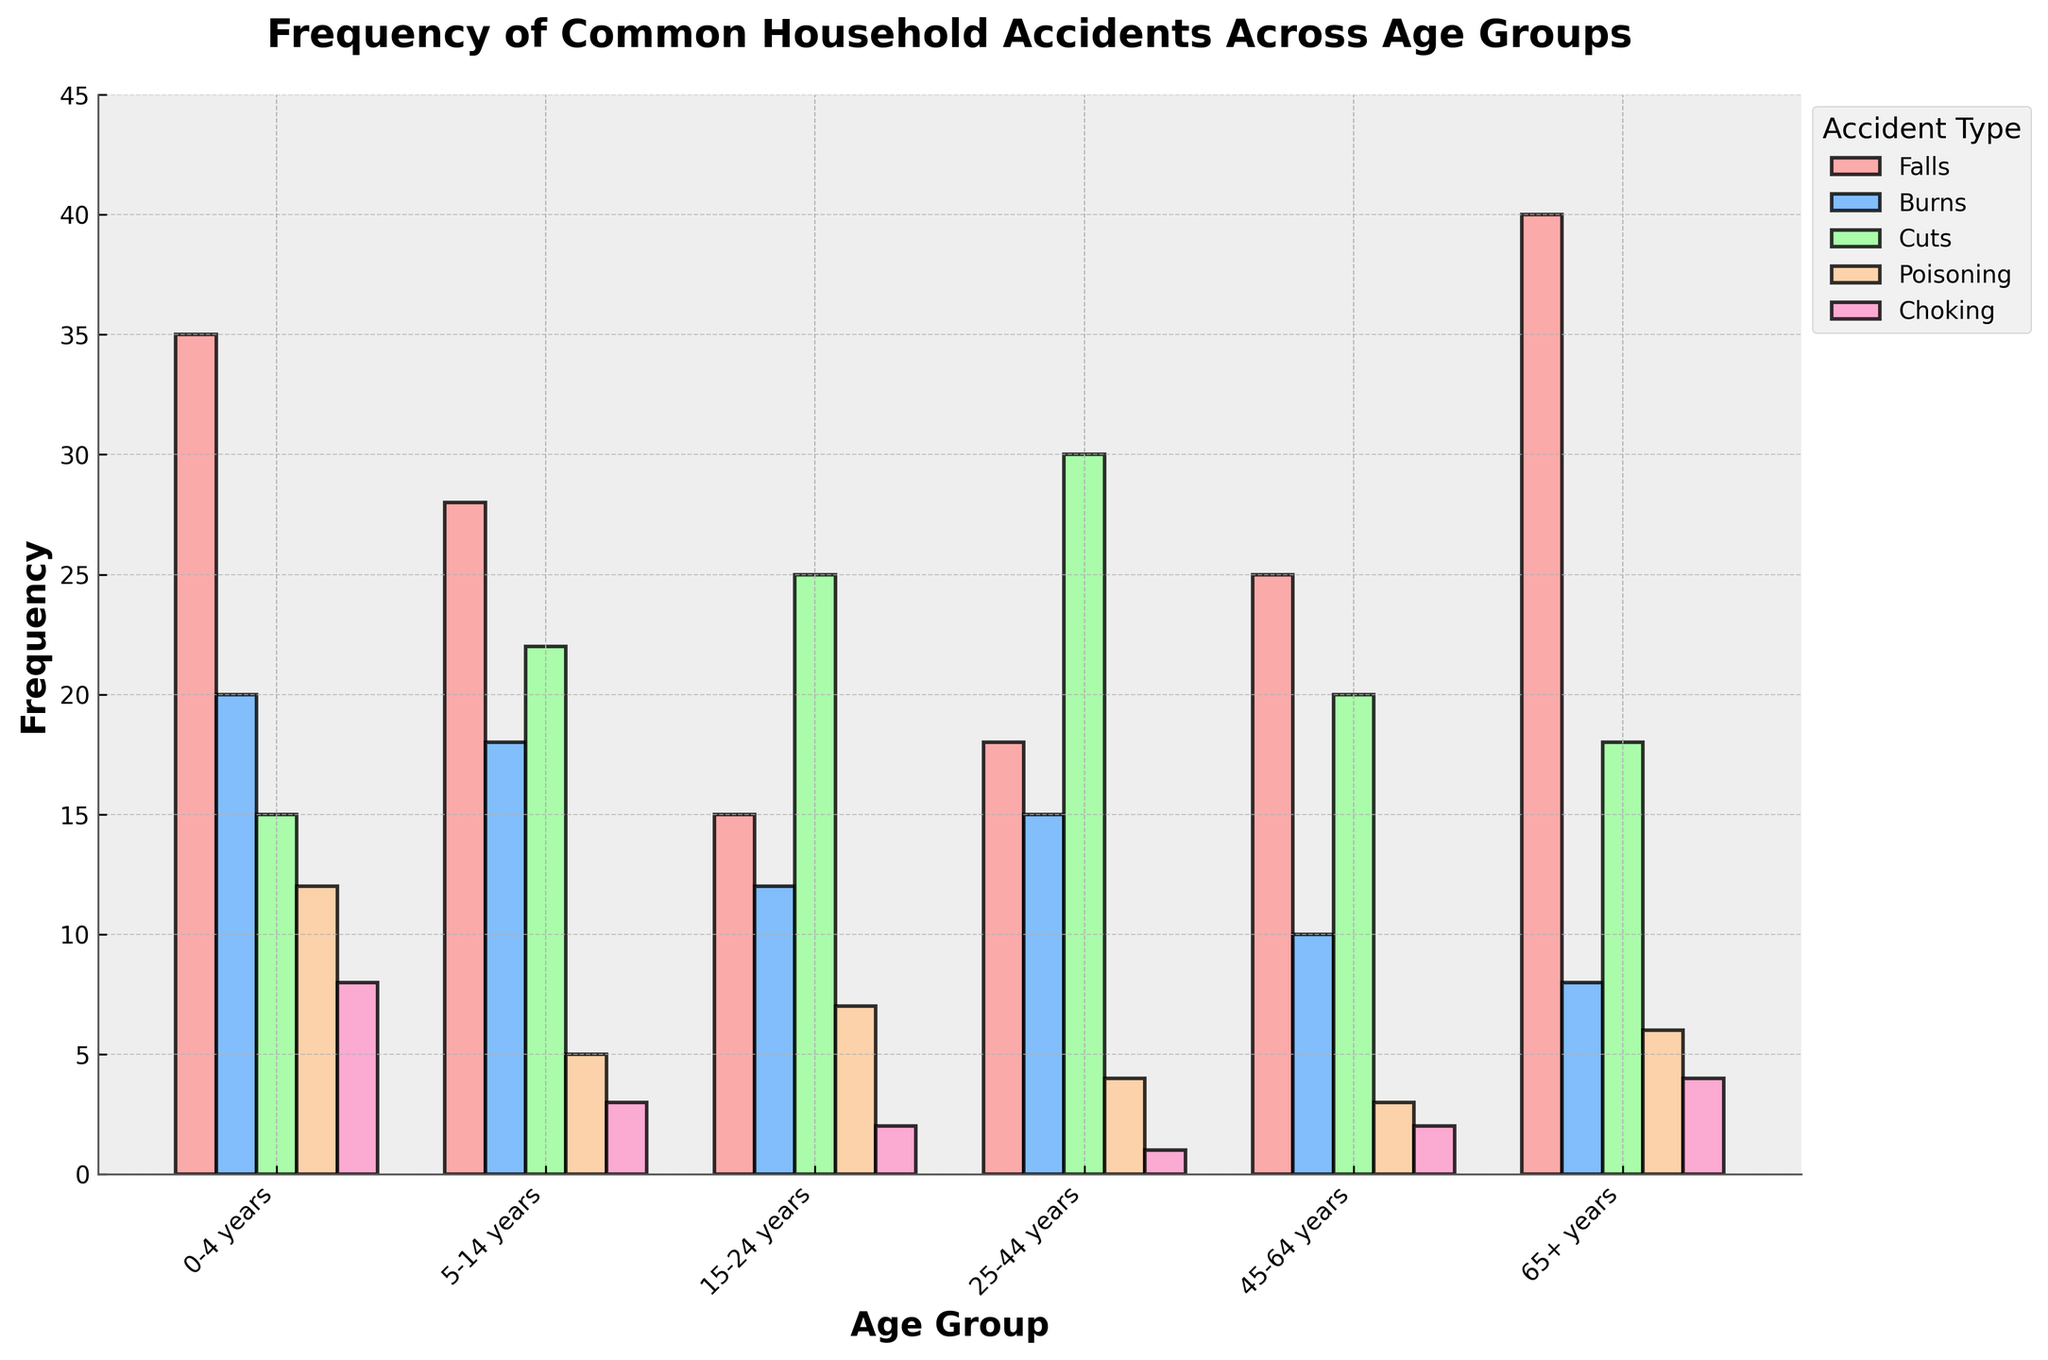Which age group has the highest frequency of falls? By looking at the height of the bars representing 'Falls' in each age group, the tallest bar corresponds to the 65+ years group.
Answer: 65+ years Which age group experiences fewer burns: 5-14 years or 45-64 years? By comparing the height of the bars representing 'Burns' for the 5-14 years group and the 45-64 years group, we can see that the 45-64 group has a lower frequency of burns.
Answer: 45-64 years What’s the difference in the frequency of cuts between the 15-24 years group and the 25-44 years group? The height for 'Cuts' in the 15-24 years group is 25 and for the 25-44 years group is 30. The difference is 30 - 25 = 5.
Answer: 5 Which age group has the lowest frequency of poisoning incidents? By examining the height of the bars for 'Poisoning' across all age groups, the 25-44 years group has the shortest bar.
Answer: 25-44 years What is the total frequency of accidents (falls, burns, cuts, poisoning, choking) for the 0-4 years group? Add the frequencies for each type of accident: 35 (Falls) + 20 (Burns) + 15 (Cuts) + 12 (Poisoning) + 8 (Choking) = 90.
Answer: 90 How does the frequency of falls in the 0-4 years group compare to the frequency of falls in the 25-44 years group? The bar for 'Falls' in the 0-4 years group is higher at 35 compared to the 18 for the 25-44 years group. Thus, the 0-4 years group has a higher frequency of falls.
Answer: 0-4 years is higher What’s the combined frequency of burns and choking in the 65+ years group? Add the frequencies for 'Burns' and 'Choking' in the 65+ years group: 8 (Burns) + 4 (Choking) = 12.
Answer: 12 Which age group experiences the most diverse types of household accidents (i.e., shows frequency for all five accident types)? By examining all age groups, each group shows data for all five types of accidents, so this is applicable for all age groups.
Answer: All age groups Compare the frequency of choking incidents across the age groups; which two groups have the closest frequencies? By comparing the heights of the bars for 'Choking' across all age groups, the 15-24 years group and the 45-64 years group both have a frequency of 2, making them the closest (although technically equal).
Answer: 15-24 and 45-64 years 